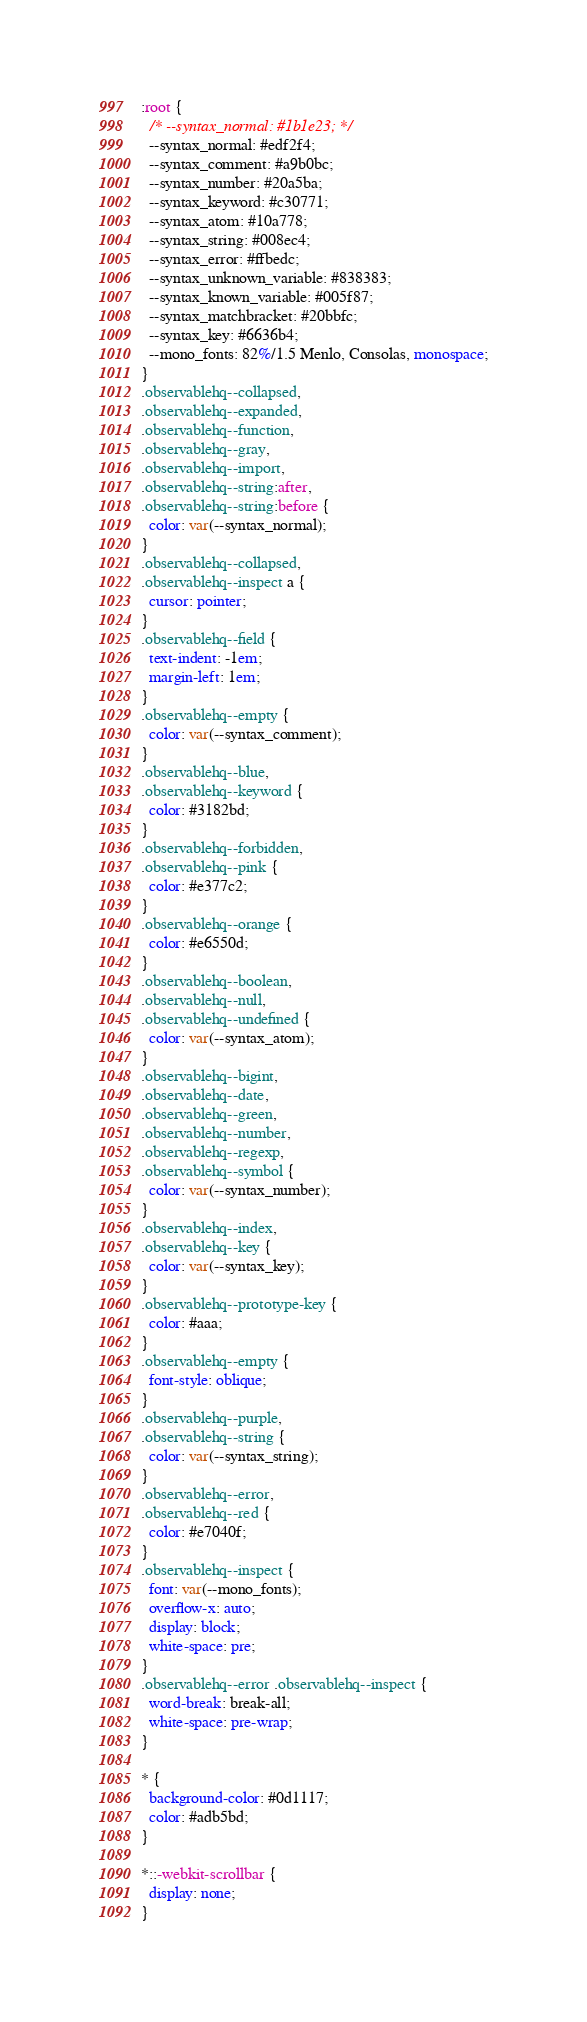<code> <loc_0><loc_0><loc_500><loc_500><_CSS_>:root {
  /* --syntax_normal: #1b1e23; */
  --syntax_normal: #edf2f4;
  --syntax_comment: #a9b0bc;
  --syntax_number: #20a5ba;
  --syntax_keyword: #c30771;
  --syntax_atom: #10a778;
  --syntax_string: #008ec4;
  --syntax_error: #ffbedc;
  --syntax_unknown_variable: #838383;
  --syntax_known_variable: #005f87;
  --syntax_matchbracket: #20bbfc;
  --syntax_key: #6636b4;
  --mono_fonts: 82%/1.5 Menlo, Consolas, monospace;
}
.observablehq--collapsed,
.observablehq--expanded,
.observablehq--function,
.observablehq--gray,
.observablehq--import,
.observablehq--string:after,
.observablehq--string:before {
  color: var(--syntax_normal);
}
.observablehq--collapsed,
.observablehq--inspect a {
  cursor: pointer;
}
.observablehq--field {
  text-indent: -1em;
  margin-left: 1em;
}
.observablehq--empty {
  color: var(--syntax_comment);
}
.observablehq--blue,
.observablehq--keyword {
  color: #3182bd;
}
.observablehq--forbidden,
.observablehq--pink {
  color: #e377c2;
}
.observablehq--orange {
  color: #e6550d;
}
.observablehq--boolean,
.observablehq--null,
.observablehq--undefined {
  color: var(--syntax_atom);
}
.observablehq--bigint,
.observablehq--date,
.observablehq--green,
.observablehq--number,
.observablehq--regexp,
.observablehq--symbol {
  color: var(--syntax_number);
}
.observablehq--index,
.observablehq--key {
  color: var(--syntax_key);
}
.observablehq--prototype-key {
  color: #aaa;
}
.observablehq--empty {
  font-style: oblique;
}
.observablehq--purple,
.observablehq--string {
  color: var(--syntax_string);
}
.observablehq--error,
.observablehq--red {
  color: #e7040f;
}
.observablehq--inspect {
  font: var(--mono_fonts);
  overflow-x: auto;
  display: block;
  white-space: pre;
}
.observablehq--error .observablehq--inspect {
  word-break: break-all;
  white-space: pre-wrap;
}

* {
  background-color: #0d1117;
  color: #adb5bd;
}

*::-webkit-scrollbar {
  display: none;
}
</code> 